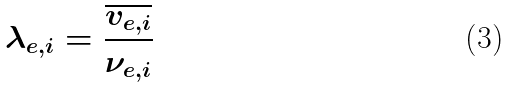Convert formula to latex. <formula><loc_0><loc_0><loc_500><loc_500>\lambda _ { e , i } = \frac { \overline { v _ { e , i } } } { \nu _ { e , i } }</formula> 